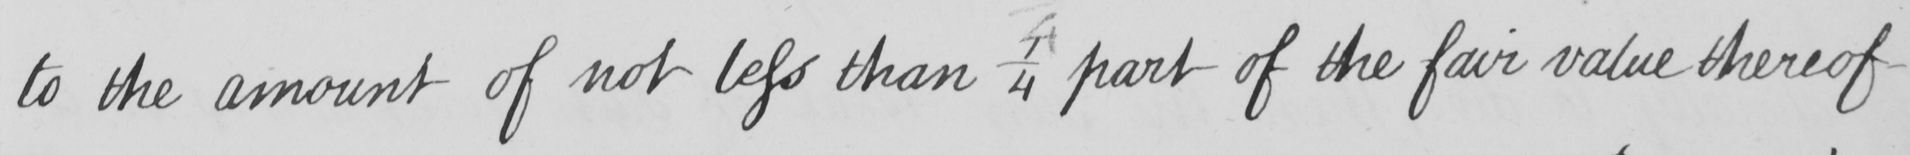What is written in this line of handwriting? to the amount of not less than 1/4 part of the fair value thereof 